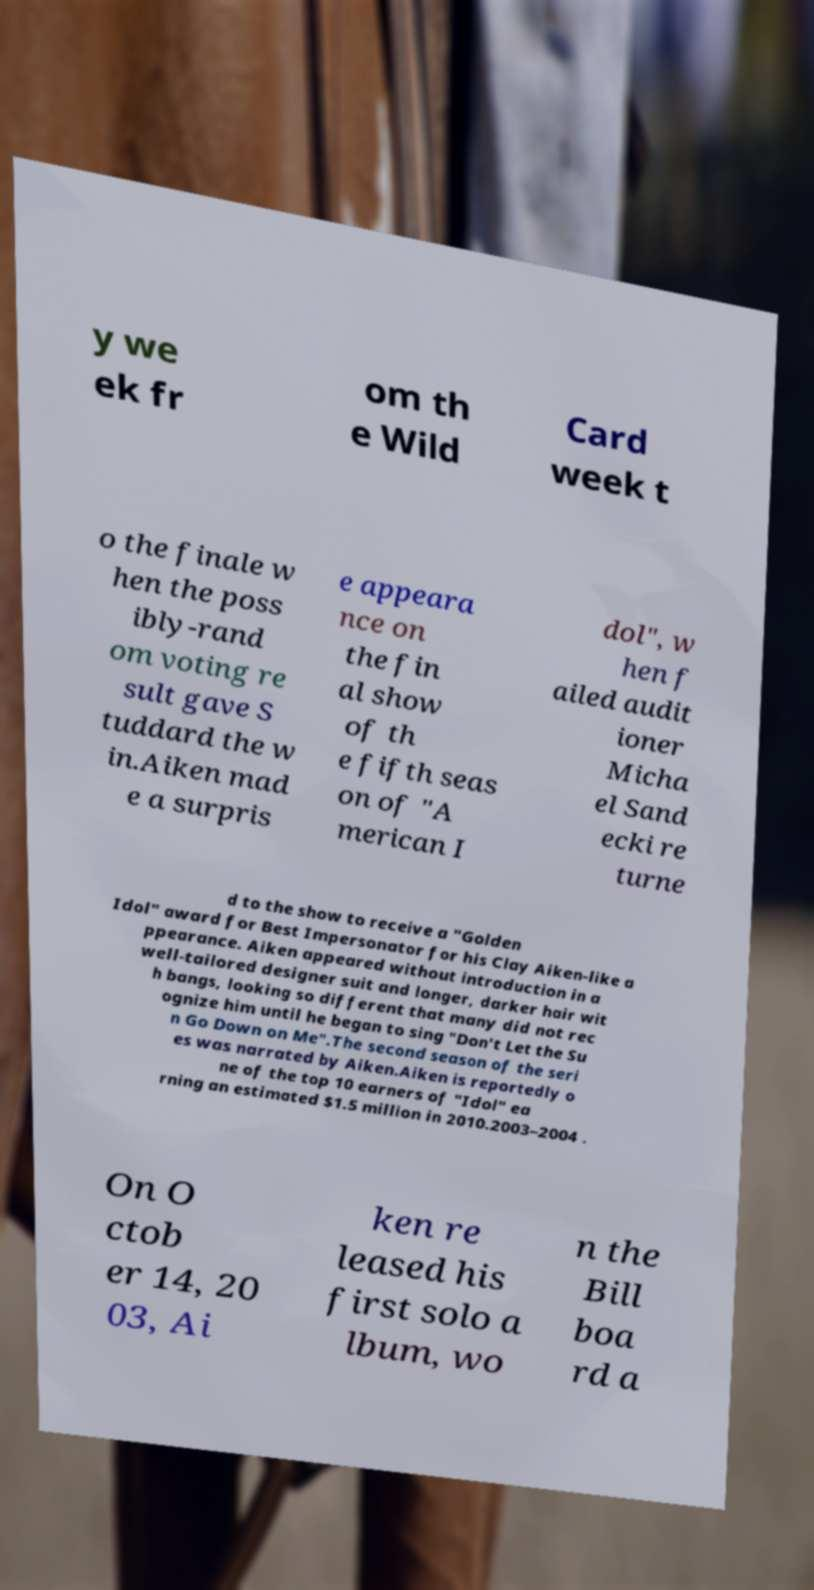Can you read and provide the text displayed in the image?This photo seems to have some interesting text. Can you extract and type it out for me? y we ek fr om th e Wild Card week t o the finale w hen the poss ibly-rand om voting re sult gave S tuddard the w in.Aiken mad e a surpris e appeara nce on the fin al show of th e fifth seas on of "A merican I dol", w hen f ailed audit ioner Micha el Sand ecki re turne d to the show to receive a "Golden Idol" award for Best Impersonator for his Clay Aiken-like a ppearance. Aiken appeared without introduction in a well-tailored designer suit and longer, darker hair wit h bangs, looking so different that many did not rec ognize him until he began to sing "Don't Let the Su n Go Down on Me".The second season of the seri es was narrated by Aiken.Aiken is reportedly o ne of the top 10 earners of "Idol" ea rning an estimated $1.5 million in 2010.2003–2004 . On O ctob er 14, 20 03, Ai ken re leased his first solo a lbum, wo n the Bill boa rd a 